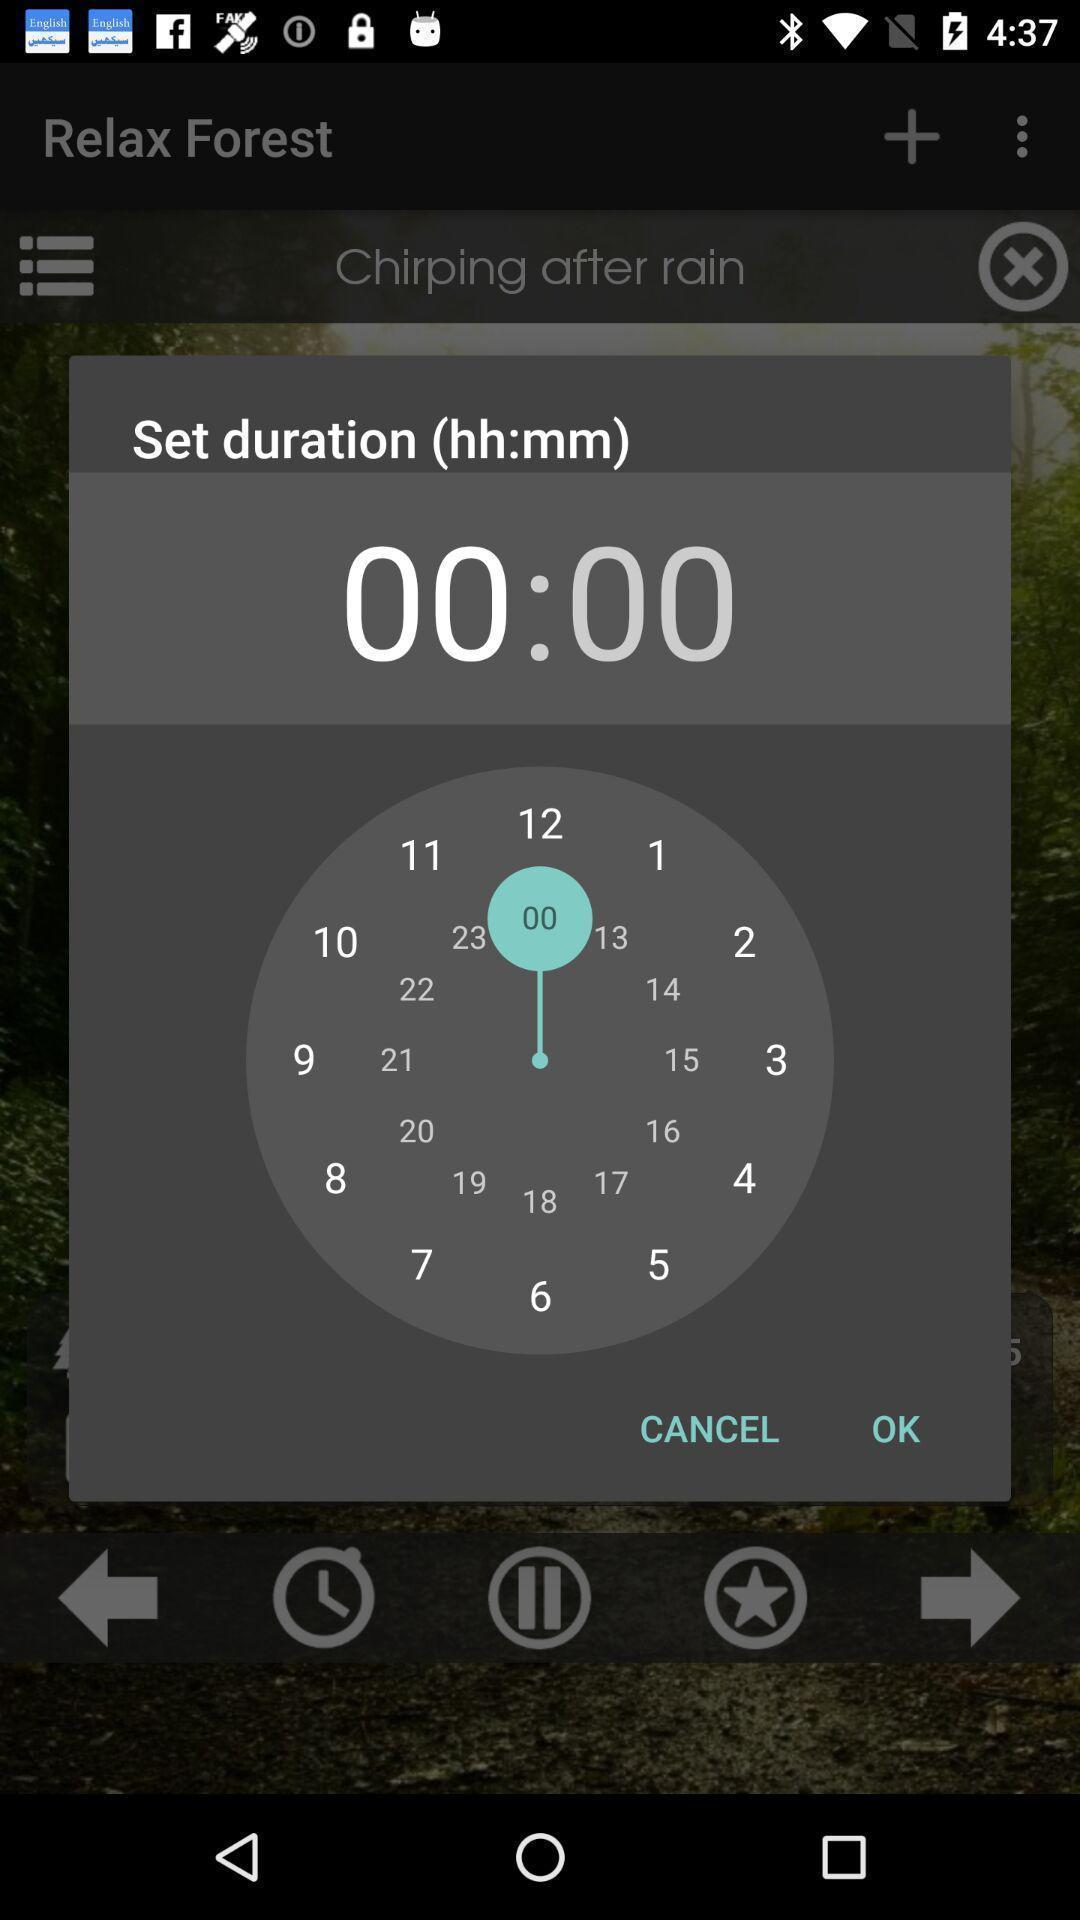Give me a narrative description of this picture. Pop-up to set time duration. 